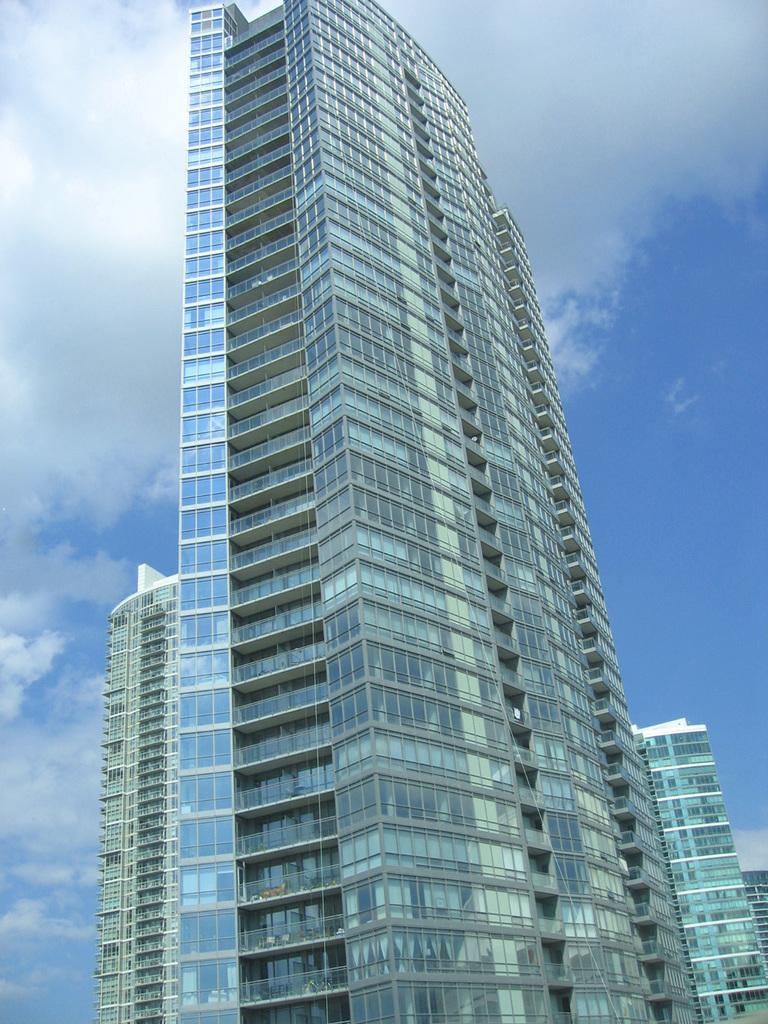What type of buildings can be seen in the image? There are glass buildings in the image. What is visible at the top of the image? The sky is visible at the top of the image. What type of soda is being sorted by texture in the image? There is no soda or sorting activity present in the image. 